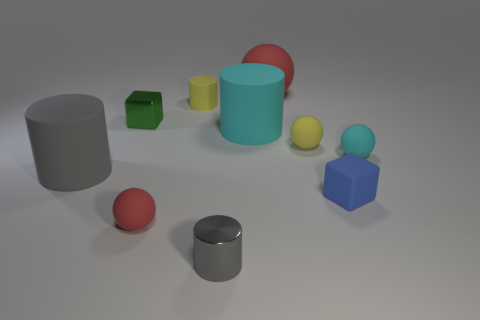Subtract all large red rubber spheres. How many spheres are left? 3 Subtract all red cylinders. Subtract all purple spheres. How many cylinders are left? 4 Subtract all spheres. How many objects are left? 6 Subtract all large things. Subtract all small shiny cylinders. How many objects are left? 6 Add 9 cyan balls. How many cyan balls are left? 10 Add 2 matte cylinders. How many matte cylinders exist? 5 Subtract 0 brown cylinders. How many objects are left? 10 